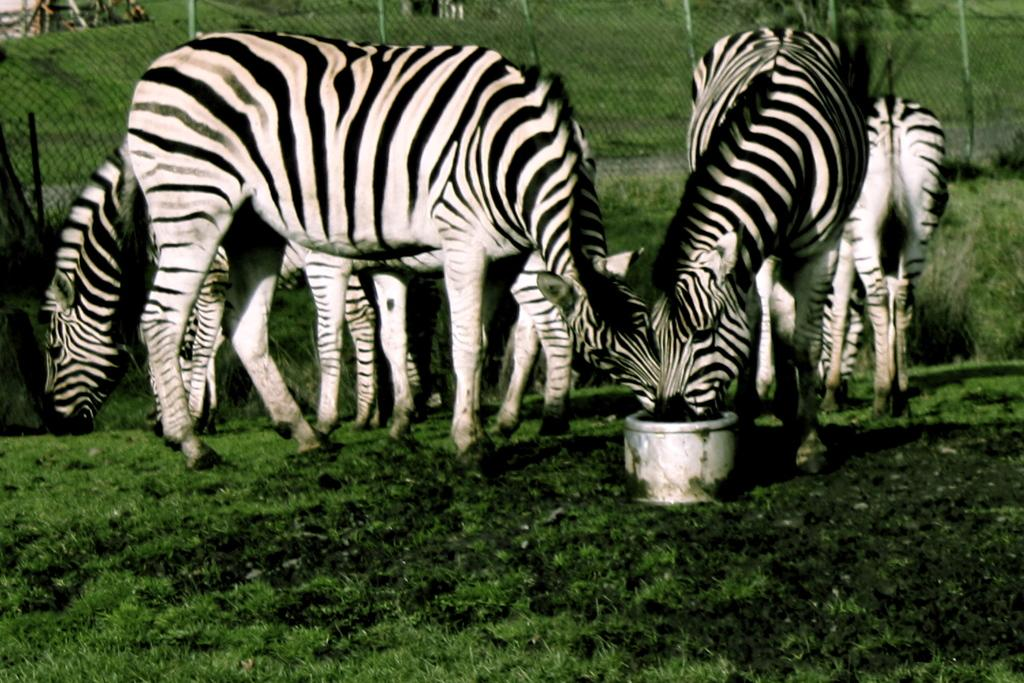What animals are in the foreground of the image? There are zebras in the foreground of the image. What is the zebras standing on? The zebras are on the grass. What can be seen in the background of the image? There is fencing, trees, and a path in the background of the image. What type of pencil can be seen in the image? There is no pencil present in the image; it features zebras on the grass with a background of fencing, trees, and a path. 